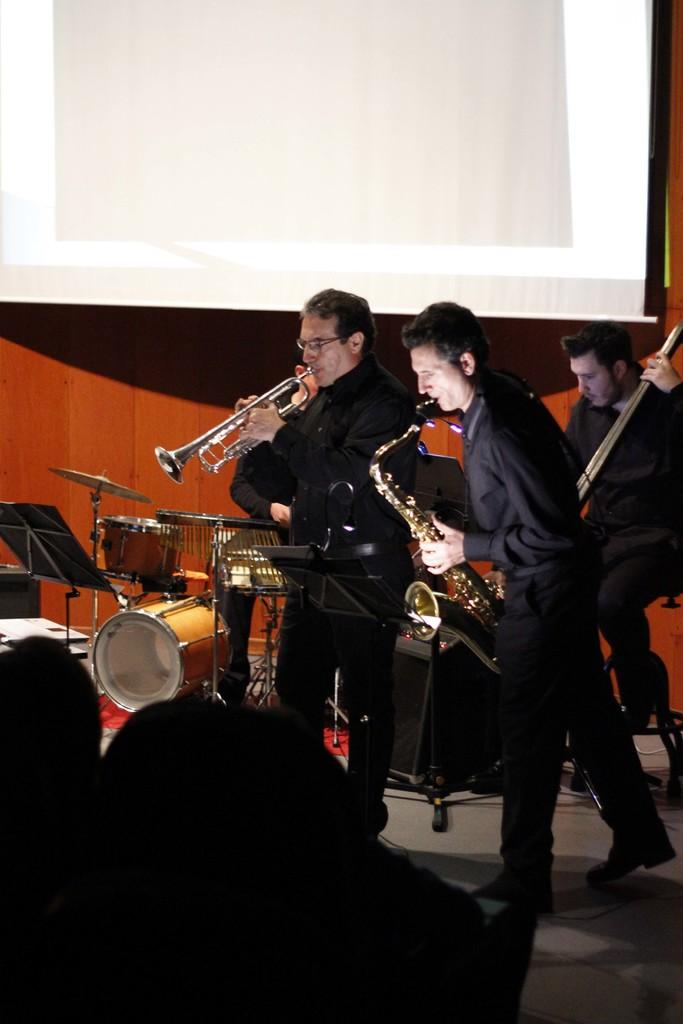What is the primary activity of the men in the image? The men in the image are holding musical instruments in their hands. What positions are the men in? Some men are sitting, while others are standing. Are there any musical instruments on the floor or walls? Yes, there are musical instruments on the floor and walls. What type of cat can be seen playing with the sleet in the image? There is no cat or sleet present in the image; the scene focuses on men holding musical instruments. 